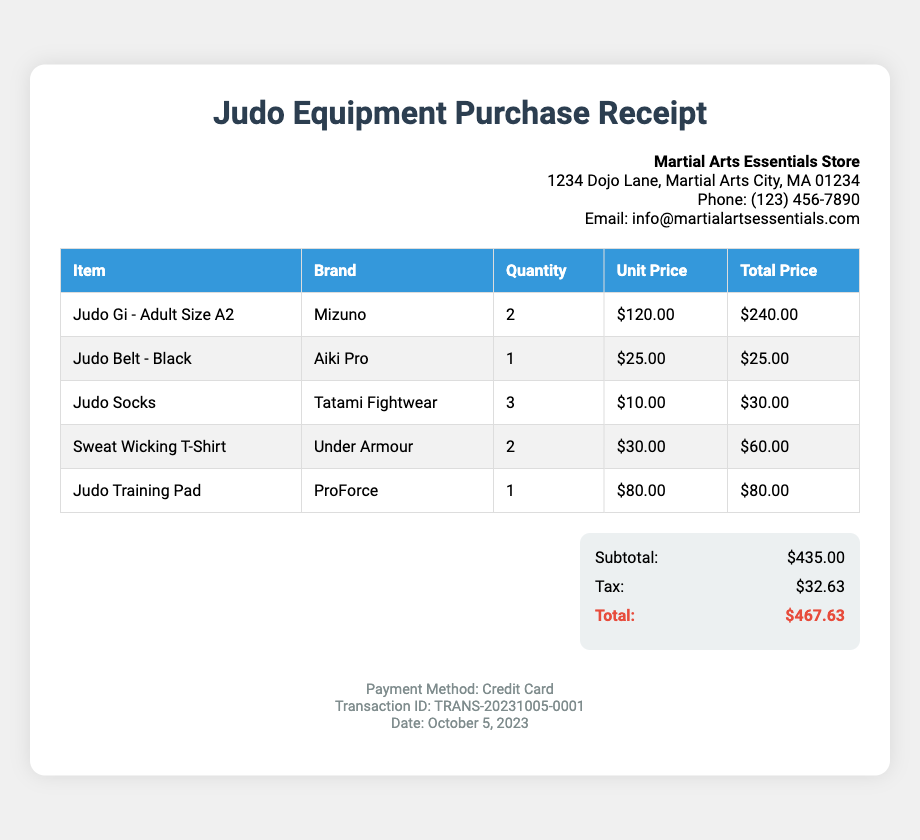what is the total amount spent? The total amount spent is listed at the end of the summary section of the receipt.
Answer: $467.63 how many Judo Gis were purchased? The quantity of Judo Gis can be found in the items table under the respective item.
Answer: 2 what brand is the Judo Belt? The brand name for the Judo Belt is mentioned in the items table.
Answer: Aiki Pro what is the subtotal amount before tax? The subtotal is provided in the summary section, just before the tax is calculated.
Answer: $435.00 how much was paid for the Judo Training Pad? The price for the Judo Training Pad is specified in the items table under the total price column.
Answer: $80.00 what is the date of the transaction? The transaction date is mentioned in the footer section of the receipt.
Answer: October 5, 2023 how many items are there in total? The total number of items can be determined by counting the items listed in the items table.
Answer: 5 what was the payment method used? The payment method used for the transaction is detailed in the footer of the receipt.
Answer: Credit Card which store issued this receipt? The name of the store that issued the receipt is in the vendor-info section at the top.
Answer: Martial Arts Essentials Store 